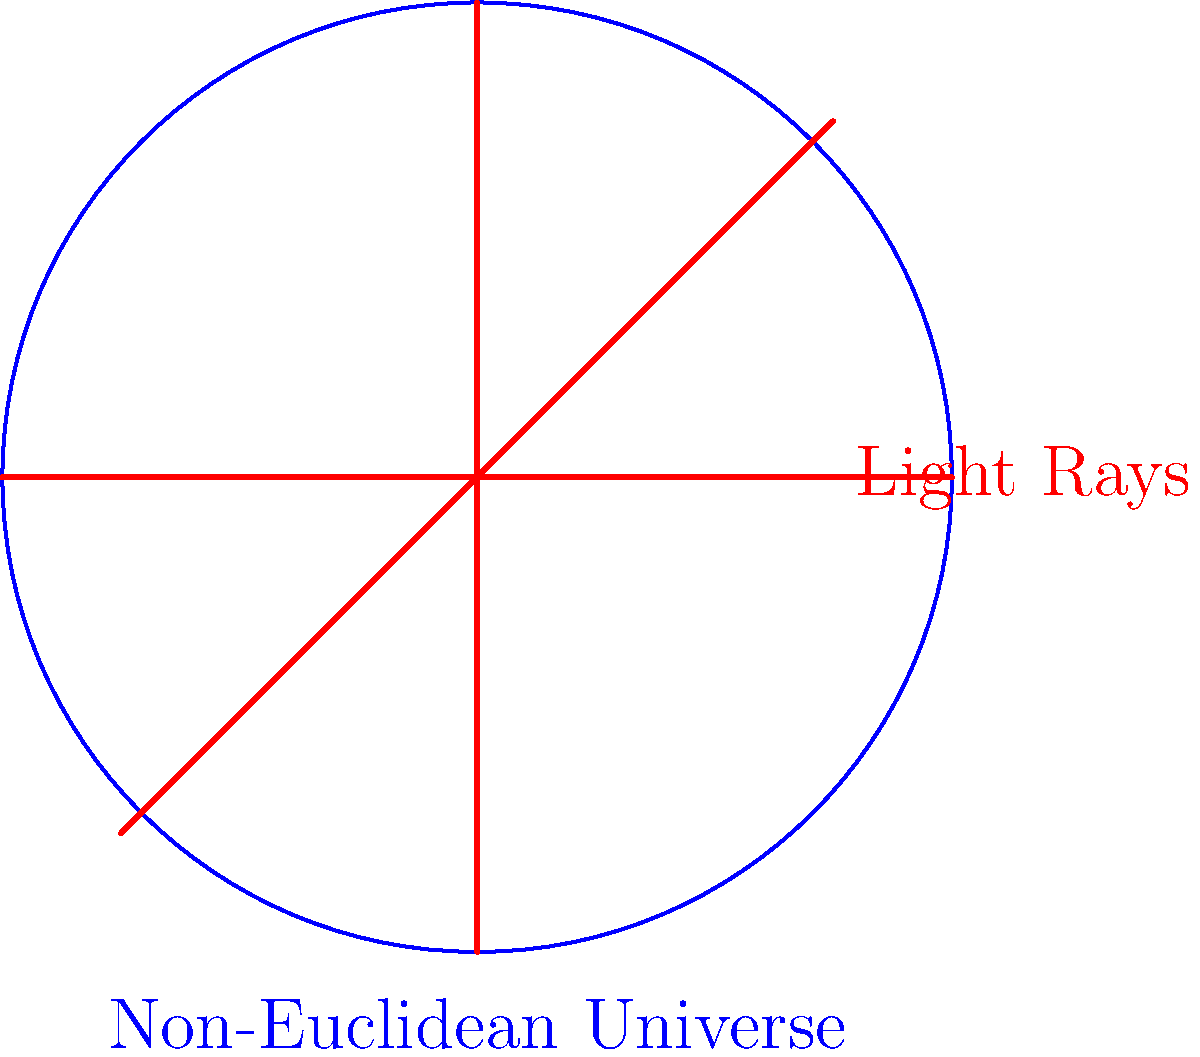In a non-Euclidean universe, as depicted in the image, how do light rays behave differently compared to our familiar Euclidean space? Consider the implications for the concept of "straight lines" in such a universe. To understand the behavior of light rays in a non-Euclidean universe, we need to consider the following steps:

1. In Euclidean geometry, light rays travel in straight lines. However, in a non-Euclidean universe, the concept of a "straight line" is different.

2. The image shows a circular representation of a non-Euclidean universe, with three red lines representing light rays.

3. These light rays appear curved within the circular boundary. This curvature represents the shortest path between two points in this non-Euclidean space.

4. In non-Euclidean geometry, the shortest path between two points is not necessarily a straight line as we understand it in Euclidean space.

5. This curved behavior of light rays is due to the curvature of space itself. In a non-Euclidean universe, space can be curved or warped.

6. The curvature of space affects the path of light, causing it to bend or curve, even though the light is following the "straightest" possible path in that curved space.

7. This concept is similar to how light bends around massive objects due to gravity in our universe, as described by Einstein's theory of general relativity.

8. In the image, all three light rays are actually following "geodesics" - the equivalent of straight lines in curved space.

9. This visualization challenges our Euclidean intuition about parallel lines and the nature of straight paths, illustrating fundamental differences between Euclidean and non-Euclidean geometries.
Answer: Light rays follow curved paths (geodesics) due to space curvature. 